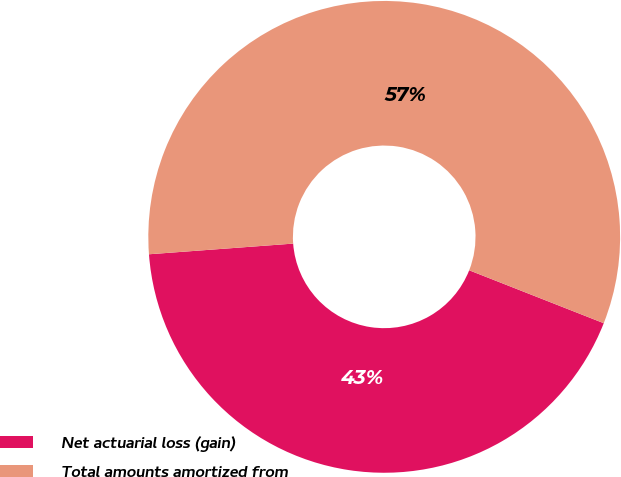Convert chart. <chart><loc_0><loc_0><loc_500><loc_500><pie_chart><fcel>Net actuarial loss (gain)<fcel>Total amounts amortized from<nl><fcel>42.86%<fcel>57.14%<nl></chart> 